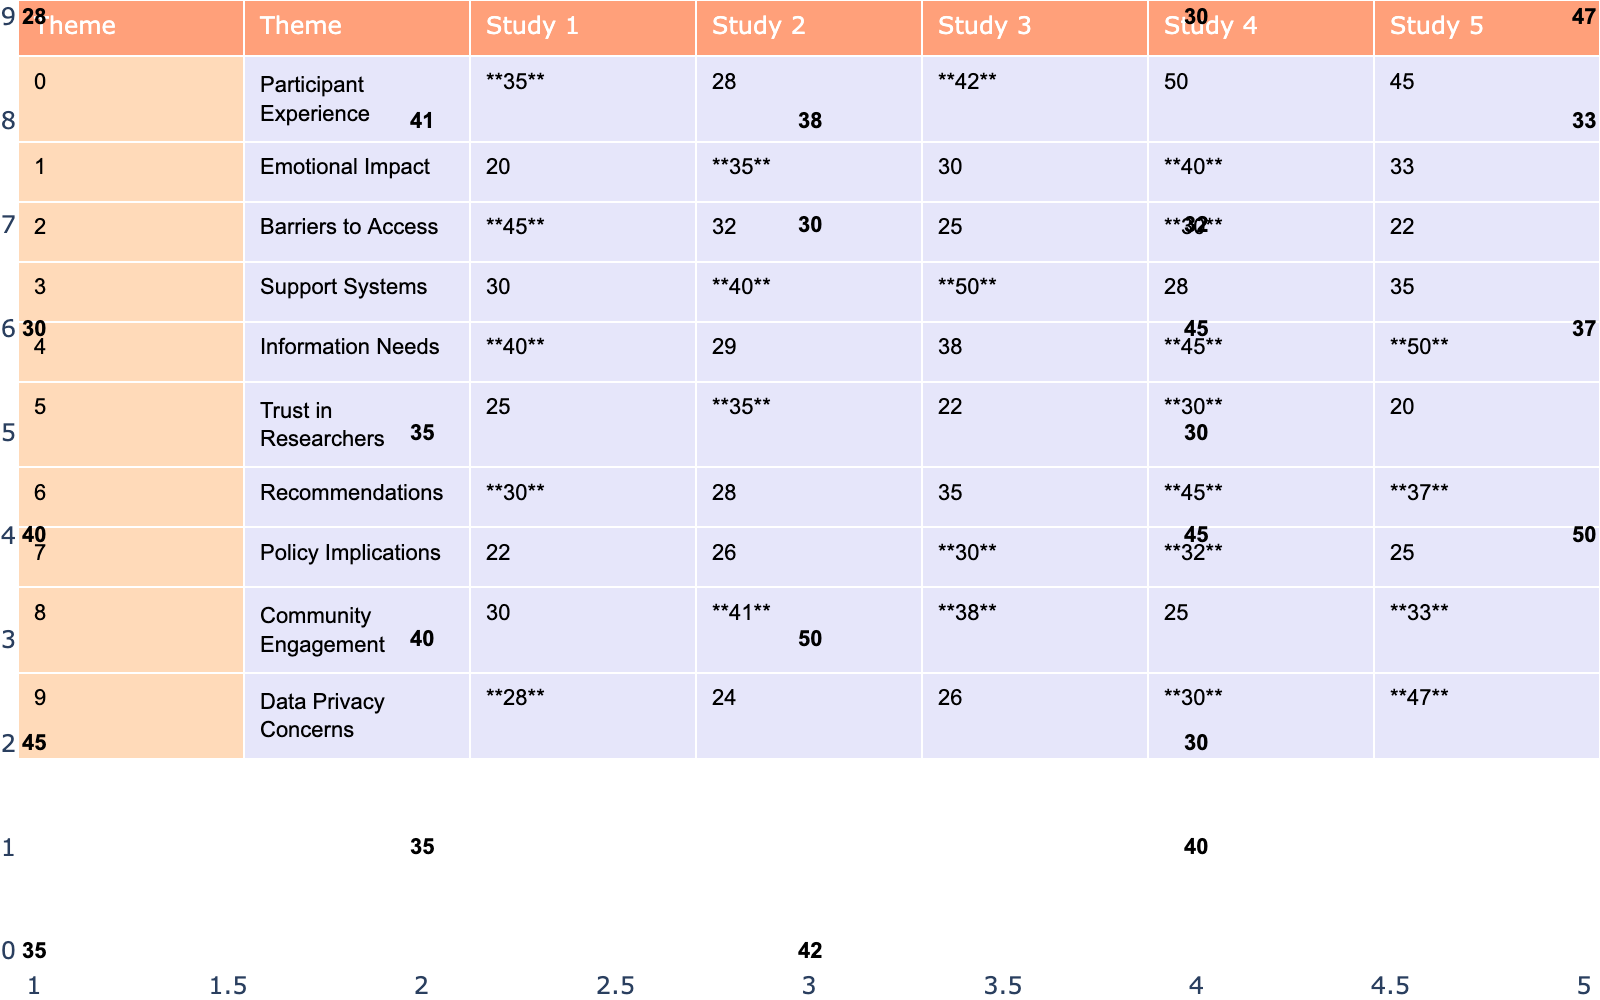What is the highest coding frequency for the theme "Participant Experience"? From the table, the highest frequency for "Participant Experience" can be found in Study 4, where it is **50**.
Answer: 50 Which theme has the lowest coding frequency across all studies? By examining the table, "Barriers to Access" shows the lowest frequency of **22** in Study 5.
Answer: 22 What is the total frequency of the theme "Emotional Impact" across all studies? Adding the frequencies for "Emotional Impact": 20 + 35 + 30 + 40 + 33 = 158.
Answer: 158 Is there any study in which the theme "Data Privacy Concerns" has a frequency higher than 30? Yes, in Study 5, "Data Privacy Concerns" has a frequency of **47**, which is higher than 30.
Answer: Yes Which theme has the second highest frequency in Study 1? In Study 1, “Barriers to Access” has a frequency of **45**, while “Participant Experience” has **35**, making "Barriers to Access" the second highest.
Answer: Barriers to Access What is the difference in coding frequency for the theme "Support Systems" between Study 2 and Study 4? The frequency for "Support Systems" is **40** in Study 2 and **50** in Study 4. The difference is 50 - 40 = 10.
Answer: 10 Which theme received the most consistent coding frequency across all studies? Evaluating the standard deviation of each theme's frequencies can reveal consistency. "Information Needs" has values 40, 29, 38, 45, 50, which suggests moderate variation. Other themes show higher ranges.
Answer: Information Needs How does the coding frequency for "Community Engagement" in Study 2 compare to "Trust in Researchers"? In Study 2, "Community Engagement" is **41** and "Trust in Researchers" is **35**. The comparison shows "Community Engagement" is higher by 41 - 35 = 6.
Answer: 6 Are there any themes where all studies recorded a coding frequency of 30 or above? Yes, both "Participant Experience" and "Emotional Impact" have values in all studies that are above 30.
Answer: Yes What is the average frequency of "Recommendations" across the studies? Adding the frequencies for "Recommendations": 30 + 28 + 35 + 45 + 37 = 175. The average is 175/5 = 35.
Answer: 35 Which two themes show the largest difference in their maximum coding frequencies across all studies? "Barriers to Access" has a maximum of **45** in Study 1, and "Participant Experience" has a maximum of **50** in Study 4. The difference is 50 - 22 = 28.
Answer: 28 